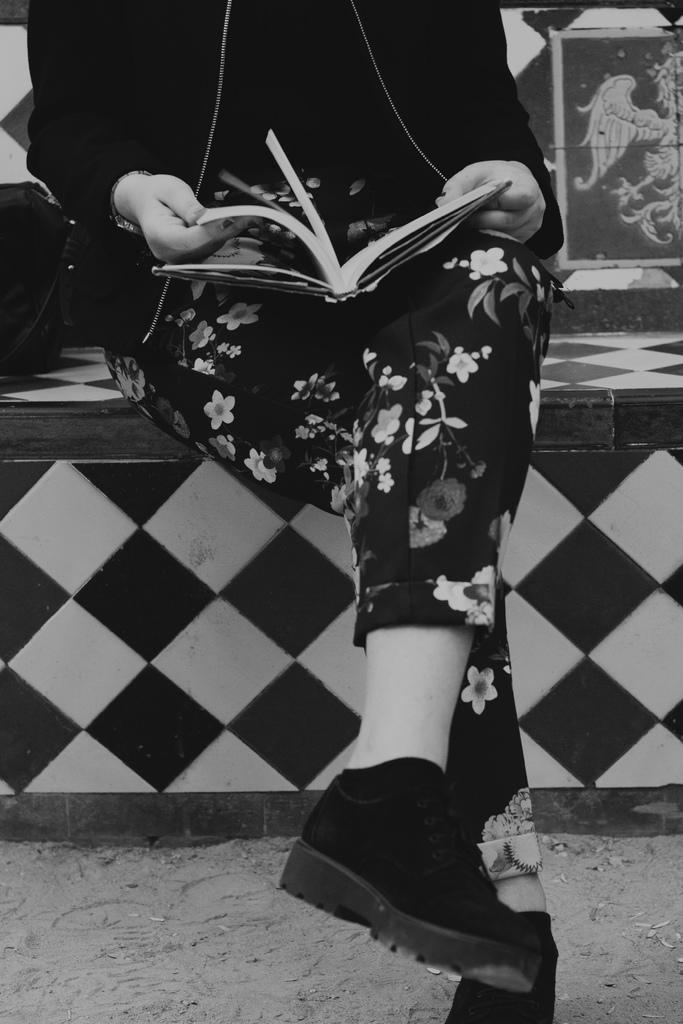Who is the main subject in the image? There is a woman in the image. What is the woman wearing? The woman is wearing a black color flower track. What is the woman holding in her hand? The woman is holding a book in her hand. Where is the woman sitting? The woman is sitting on a black and white bench. What type of fan is visible in the image? There is no fan present in the image. What kind of rail can be seen near the woman in the image? There is no rail visible in the image. 